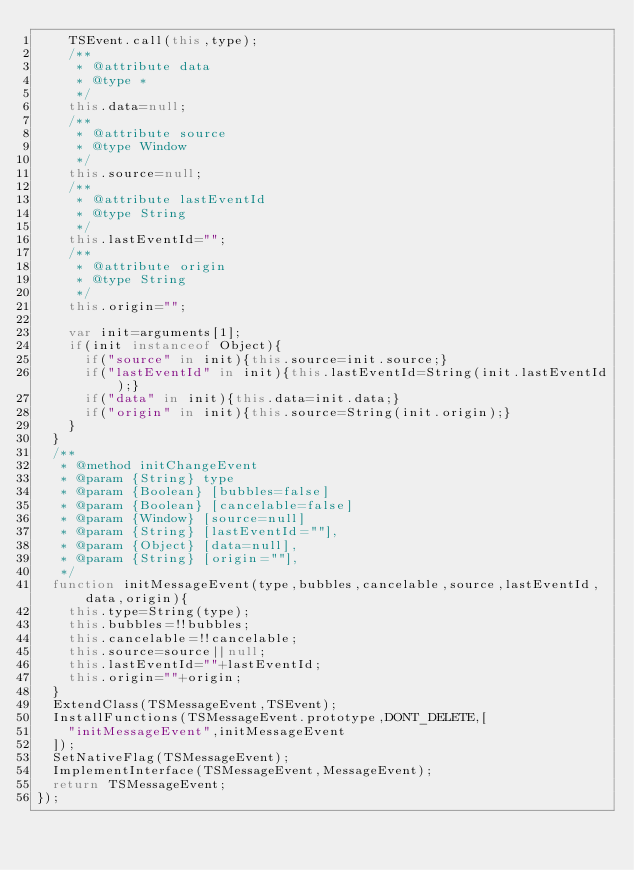Convert code to text. <code><loc_0><loc_0><loc_500><loc_500><_JavaScript_>		TSEvent.call(this,type);
		/**
		 * @attribute data
		 * @type *
		 */
		this.data=null;
		/**
		 * @attribute source
		 * @type Window
		 */
		this.source=null;
		/**
		 * @attribute lastEventId
		 * @type String
		 */
		this.lastEventId="";
		/**
		 * @attribute origin
		 * @type String
		 */
		this.origin="";
		
		var init=arguments[1];
		if(init instanceof Object){
			if("source" in init){this.source=init.source;}
			if("lastEventId" in init){this.lastEventId=String(init.lastEventId);}
			if("data" in init){this.data=init.data;}
			if("origin" in init){this.source=String(init.origin);}
		}
	}
	/**
	 * @method initChangeEvent
	 * @param {String} type
	 * @param {Boolean} [bubbles=false]
	 * @param {Boolean} [cancelable=false]
	 * @param {Window} [source=null]
	 * @param {String} [lastEventId=""],
	 * @param {Object} [data=null],
	 * @param {String} [origin=""],
	 */
	function initMessageEvent(type,bubbles,cancelable,source,lastEventId,data,origin){
		this.type=String(type);
		this.bubbles=!!bubbles;
		this.cancelable=!!cancelable;
		this.source=source||null;
		this.lastEventId=""+lastEventId;
		this.origin=""+origin;
	}
	ExtendClass(TSMessageEvent,TSEvent);
	InstallFunctions(TSMessageEvent.prototype,DONT_DELETE,[
		"initMessageEvent",initMessageEvent
	]);
	SetNativeFlag(TSMessageEvent);
	ImplementInterface(TSMessageEvent,MessageEvent);
	return TSMessageEvent;
});</code> 